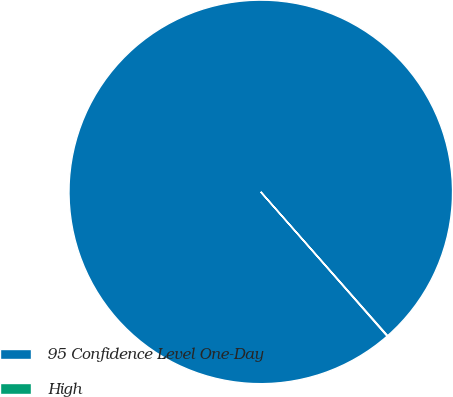Convert chart. <chart><loc_0><loc_0><loc_500><loc_500><pie_chart><fcel>95 Confidence Level One-Day<fcel>High<nl><fcel>99.95%<fcel>0.05%<nl></chart> 